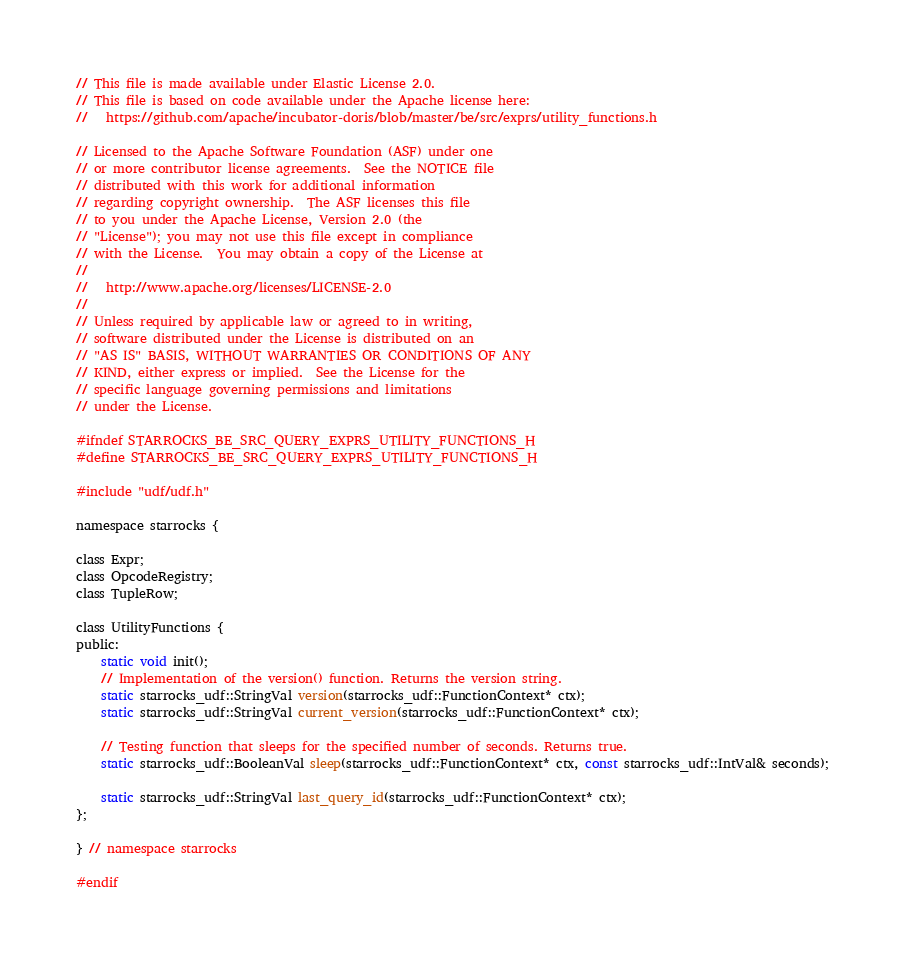<code> <loc_0><loc_0><loc_500><loc_500><_C_>// This file is made available under Elastic License 2.0.
// This file is based on code available under the Apache license here:
//   https://github.com/apache/incubator-doris/blob/master/be/src/exprs/utility_functions.h

// Licensed to the Apache Software Foundation (ASF) under one
// or more contributor license agreements.  See the NOTICE file
// distributed with this work for additional information
// regarding copyright ownership.  The ASF licenses this file
// to you under the Apache License, Version 2.0 (the
// "License"); you may not use this file except in compliance
// with the License.  You may obtain a copy of the License at
//
//   http://www.apache.org/licenses/LICENSE-2.0
//
// Unless required by applicable law or agreed to in writing,
// software distributed under the License is distributed on an
// "AS IS" BASIS, WITHOUT WARRANTIES OR CONDITIONS OF ANY
// KIND, either express or implied.  See the License for the
// specific language governing permissions and limitations
// under the License.

#ifndef STARROCKS_BE_SRC_QUERY_EXPRS_UTILITY_FUNCTIONS_H
#define STARROCKS_BE_SRC_QUERY_EXPRS_UTILITY_FUNCTIONS_H

#include "udf/udf.h"

namespace starrocks {

class Expr;
class OpcodeRegistry;
class TupleRow;

class UtilityFunctions {
public:
    static void init();
    // Implementation of the version() function. Returns the version string.
    static starrocks_udf::StringVal version(starrocks_udf::FunctionContext* ctx);
    static starrocks_udf::StringVal current_version(starrocks_udf::FunctionContext* ctx);

    // Testing function that sleeps for the specified number of seconds. Returns true.
    static starrocks_udf::BooleanVal sleep(starrocks_udf::FunctionContext* ctx, const starrocks_udf::IntVal& seconds);

    static starrocks_udf::StringVal last_query_id(starrocks_udf::FunctionContext* ctx);
};

} // namespace starrocks

#endif
</code> 